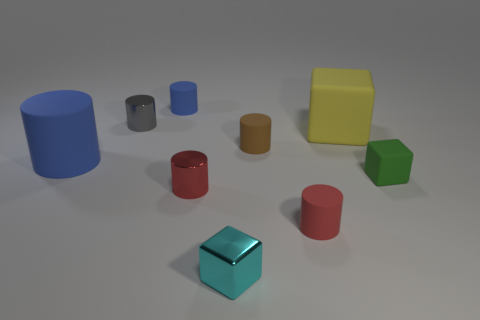Subtract all gray cylinders. How many cylinders are left? 5 Subtract all brown cylinders. How many cylinders are left? 5 Subtract all yellow cylinders. Subtract all blue balls. How many cylinders are left? 6 Subtract all blocks. How many objects are left? 6 Subtract 0 gray spheres. How many objects are left? 9 Subtract all large gray matte blocks. Subtract all yellow matte things. How many objects are left? 8 Add 9 cyan shiny cubes. How many cyan shiny cubes are left? 10 Add 3 gray cylinders. How many gray cylinders exist? 4 